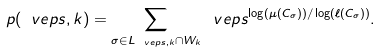<formula> <loc_0><loc_0><loc_500><loc_500>p ( \ v e p s , k ) = \sum _ { \sigma \in L _ { \ v e p s , k } \cap W _ { k } } \ v e p s ^ { \log ( \mu ( C _ { \sigma } ) ) / \log ( \ell ( C _ { \sigma } ) ) } .</formula> 